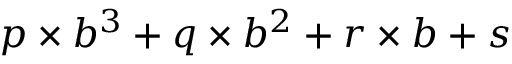<formula> <loc_0><loc_0><loc_500><loc_500>p \times b ^ { 3 } + q \times b ^ { 2 } + r \times b + s</formula> 